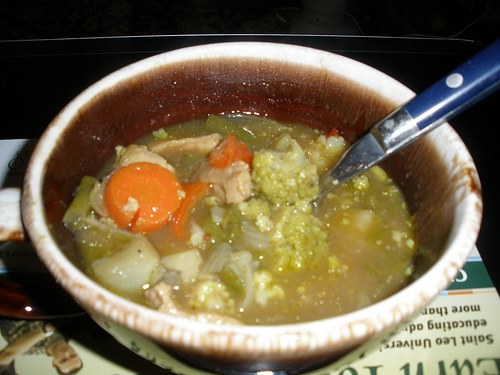Create a dialogue between two chefs discussing the recipe for this soup. Chef A: 'Have you tried my new vegetable soup recipe?'
Chef B: 'No, but it looks delicious! What’s in it?'
Chef A: 'I started with a rich broth, then added carrots, onions, broccoli, and some chunks of tender meat. I simmered everything together to let the flavors meld beautifully.'
Chef B: 'Sounds amazing. Did you use any special seasonings?'
Chef A: 'Just a bit of salt, pepper, and a hint of thyme and bay leaf for some herbal notes. It's all about letting the natural flavors of the ingredients shine.'
Chef B: 'I can't wait to try it. I might add some green peas for a bit of sweetness and additional texture.'
Chef A: 'Great idea! That would complement the other vegetables perfectly.' 